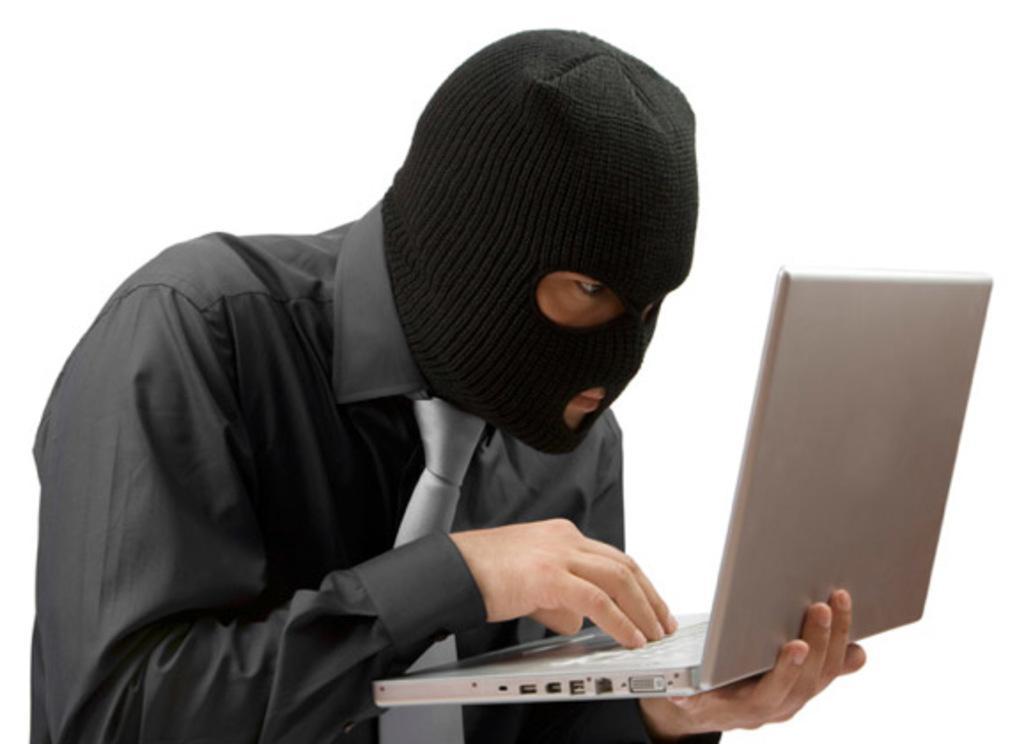How would you summarize this image in a sentence or two? In this picture I can see a man wearing a black shirt and a black monkey cap on his head and I see that he is holding a laptop and I can see the white color background. 